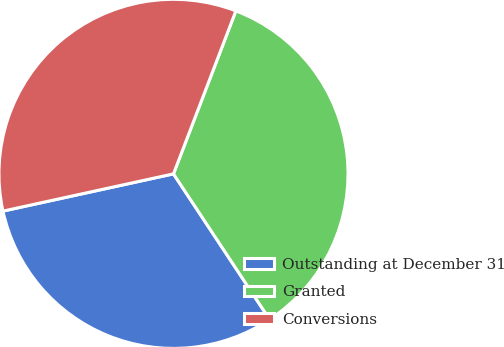<chart> <loc_0><loc_0><loc_500><loc_500><pie_chart><fcel>Outstanding at December 31<fcel>Granted<fcel>Conversions<nl><fcel>30.87%<fcel>34.89%<fcel>34.24%<nl></chart> 